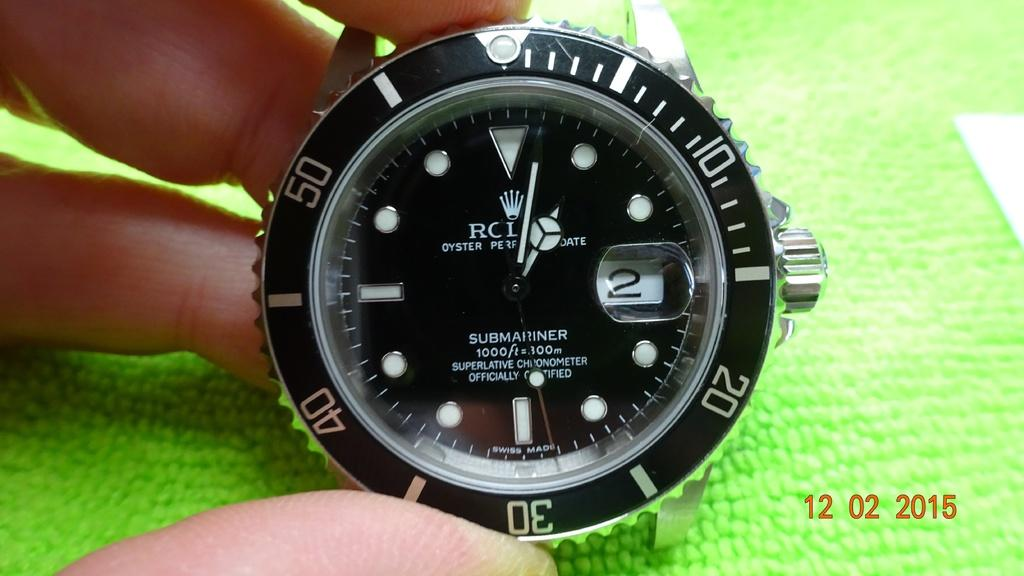<image>
Write a terse but informative summary of the picture. Person holding a watch which saysa "Submariner" on it. 